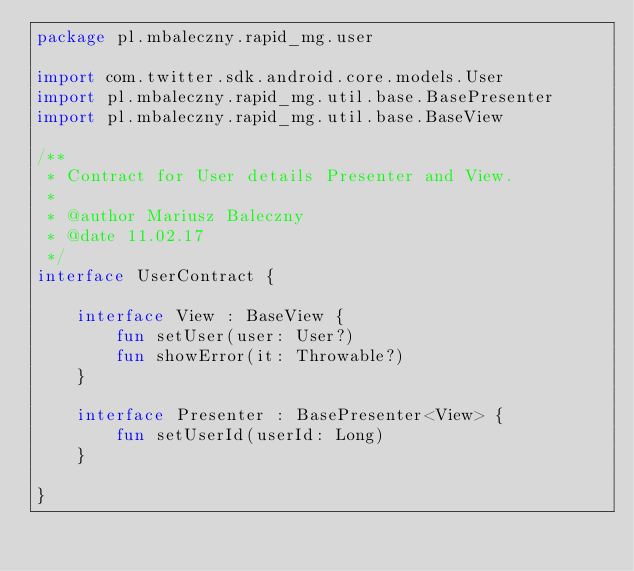<code> <loc_0><loc_0><loc_500><loc_500><_Kotlin_>package pl.mbaleczny.rapid_mg.user

import com.twitter.sdk.android.core.models.User
import pl.mbaleczny.rapid_mg.util.base.BasePresenter
import pl.mbaleczny.rapid_mg.util.base.BaseView

/**
 * Contract for User details Presenter and View.
 *
 * @author Mariusz Baleczny
 * @date 11.02.17
 */
interface UserContract {

    interface View : BaseView {
        fun setUser(user: User?)
        fun showError(it: Throwable?)
    }

    interface Presenter : BasePresenter<View> {
        fun setUserId(userId: Long)
    }

}</code> 